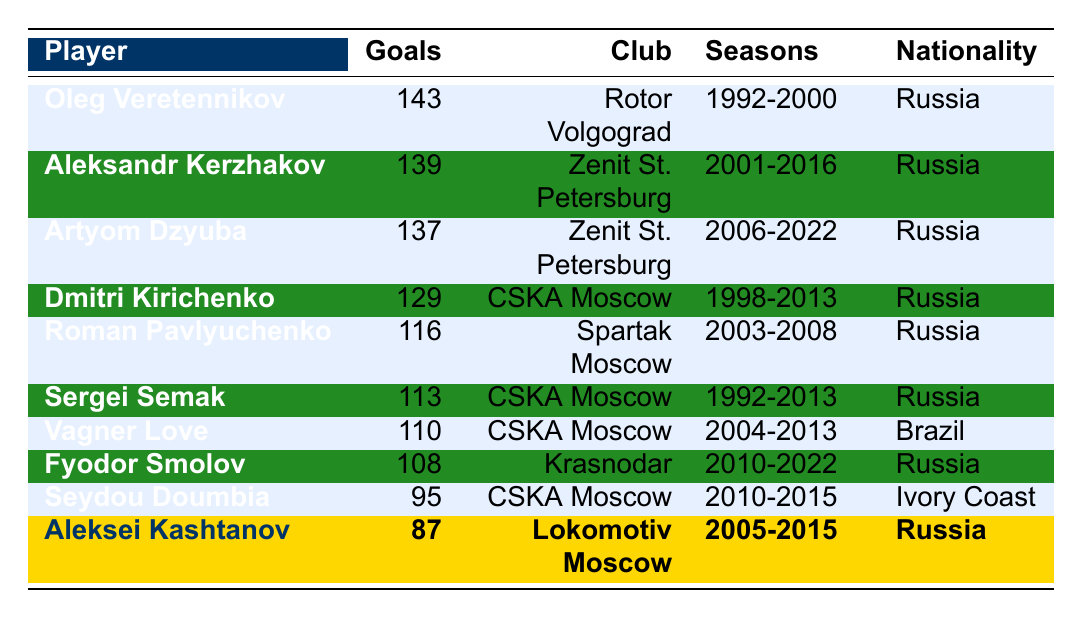What is the highest number of goals scored by a player in the Russian Premier League history? The table shows that Oleg Veretennikov has scored the highest number of goals, totaling 143.
Answer: 143 Which club did Aleksandr Kerzhakov score most of his goals for? According to the table, Aleksandr Kerzhakov scored most of his goals, 139, playing for Zenit St. Petersburg.
Answer: Zenit St. Petersburg How many goals did Aleksei Kashtanov score during his career in the Russian Premier League? The table indicates that Aleksei Kashtanov scored a total of 87 goals.
Answer: 87 Which player scored more goals: Roman Pavlyuchenko or Fyodor Smolov? The table shows Roman Pavlyuchenko with 116 goals and Fyodor Smolov with 108 goals, so Roman Pavlyuchenko scored more.
Answer: Roman Pavlyuchenko How many goals in total did the top three goalscorers score? The top three goalscorers scored 143 (Veretennikov) + 139 (Kerzhakov) + 137 (Dzyuba) = 419 goals.
Answer: 419 Is there any player in the top scorers list from outside Russia? Vagner Love from Brazil is listed in the table, indicating that there is a player from outside Russia in the top scorers list.
Answer: Yes What is the average number of goals scored by the listed players? To find the average, sum all goals: 143 + 139 + 137 + 129 + 116 + 113 + 110 + 108 + 95 + 87 = 1,301. There are 10 players, so the average is 1,301/10 = 130.1.
Answer: 130.1 Who has the longest playing career among the top goalscorers? The table shows the seasons for each player. Oleg Veretennikov played from 1992 to 2000 (8 years), while most others have shorter ranges, indicating he has the longest career among the top goalscorers.
Answer: Oleg Veretennikov How many goals did players from CSKA Moscow score in total? The table shows that CSKA Moscow players scored 129 (Kirichenko) + 113 (Semak) + 110 (Vagner Love) + 95 (Doumbia) = 447 goals in total.
Answer: 447 Did any player who scored fewer than 100 goals belong to a club with multiple top scorers? Yes, Seydou Doumbia scored 95 goals and also played for CSKA Moscow, which has other top scorers listed.
Answer: Yes 